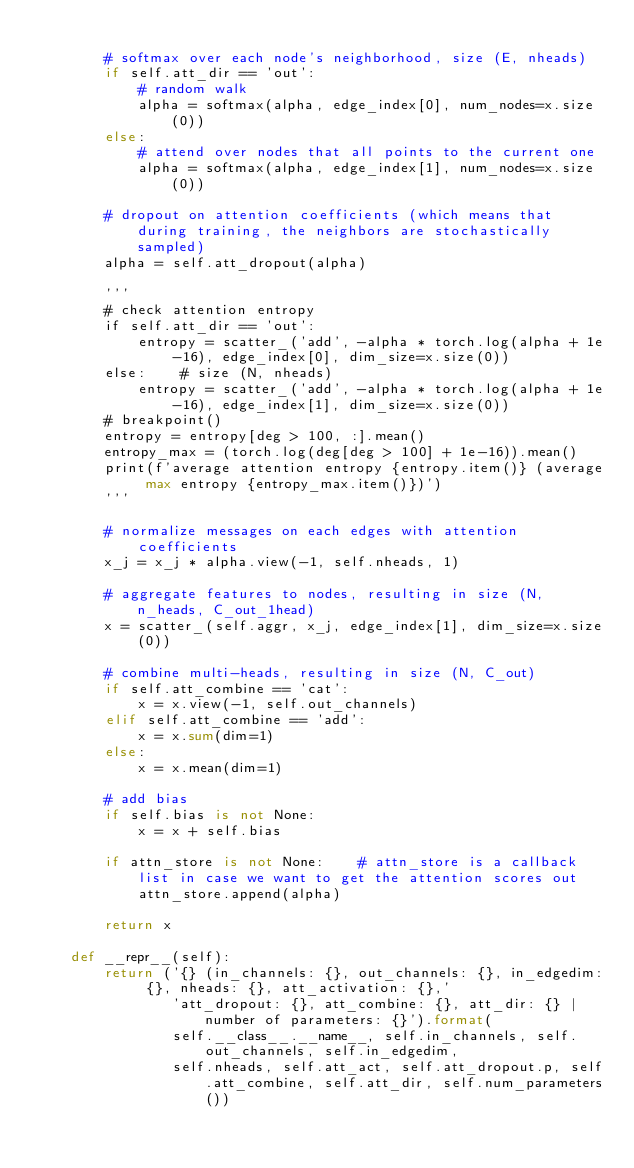<code> <loc_0><loc_0><loc_500><loc_500><_Python_>
        # softmax over each node's neighborhood, size (E, nheads)
        if self.att_dir == 'out':
            # random walk
            alpha = softmax(alpha, edge_index[0], num_nodes=x.size(0))
        else:
            # attend over nodes that all points to the current one
            alpha = softmax(alpha, edge_index[1], num_nodes=x.size(0))

        # dropout on attention coefficients (which means that during training, the neighbors are stochastically sampled)
        alpha = self.att_dropout(alpha)

        ''' 
        # check attention entropy
        if self.att_dir == 'out':
            entropy = scatter_('add', -alpha * torch.log(alpha + 1e-16), edge_index[0], dim_size=x.size(0))
        else:    # size (N, nheads)
            entropy = scatter_('add', -alpha * torch.log(alpha + 1e-16), edge_index[1], dim_size=x.size(0))
        # breakpoint()
        entropy = entropy[deg > 100, :].mean()
        entropy_max = (torch.log(deg[deg > 100] + 1e-16)).mean()
        print(f'average attention entropy {entropy.item()} (average max entropy {entropy_max.item()})')
        '''

        # normalize messages on each edges with attention coefficients
        x_j = x_j * alpha.view(-1, self.nheads, 1)

        # aggregate features to nodes, resulting in size (N, n_heads, C_out_1head)
        x = scatter_(self.aggr, x_j, edge_index[1], dim_size=x.size(0))

        # combine multi-heads, resulting in size (N, C_out)
        if self.att_combine == 'cat':
            x = x.view(-1, self.out_channels)
        elif self.att_combine == 'add':
            x = x.sum(dim=1)
        else:
            x = x.mean(dim=1)

        # add bias
        if self.bias is not None:
            x = x + self.bias
  
        if attn_store is not None:    # attn_store is a callback list in case we want to get the attention scores out
            attn_store.append(alpha)

        return x

    def __repr__(self):
        return ('{} (in_channels: {}, out_channels: {}, in_edgedim: {}, nheads: {}, att_activation: {},'
                'att_dropout: {}, att_combine: {}, att_dir: {} | number of parameters: {}').format(
                self.__class__.__name__, self.in_channels, self.out_channels, self.in_edgedim,
                self.nheads, self.att_act, self.att_dropout.p, self.att_combine, self.att_dir, self.num_parameters())
</code> 